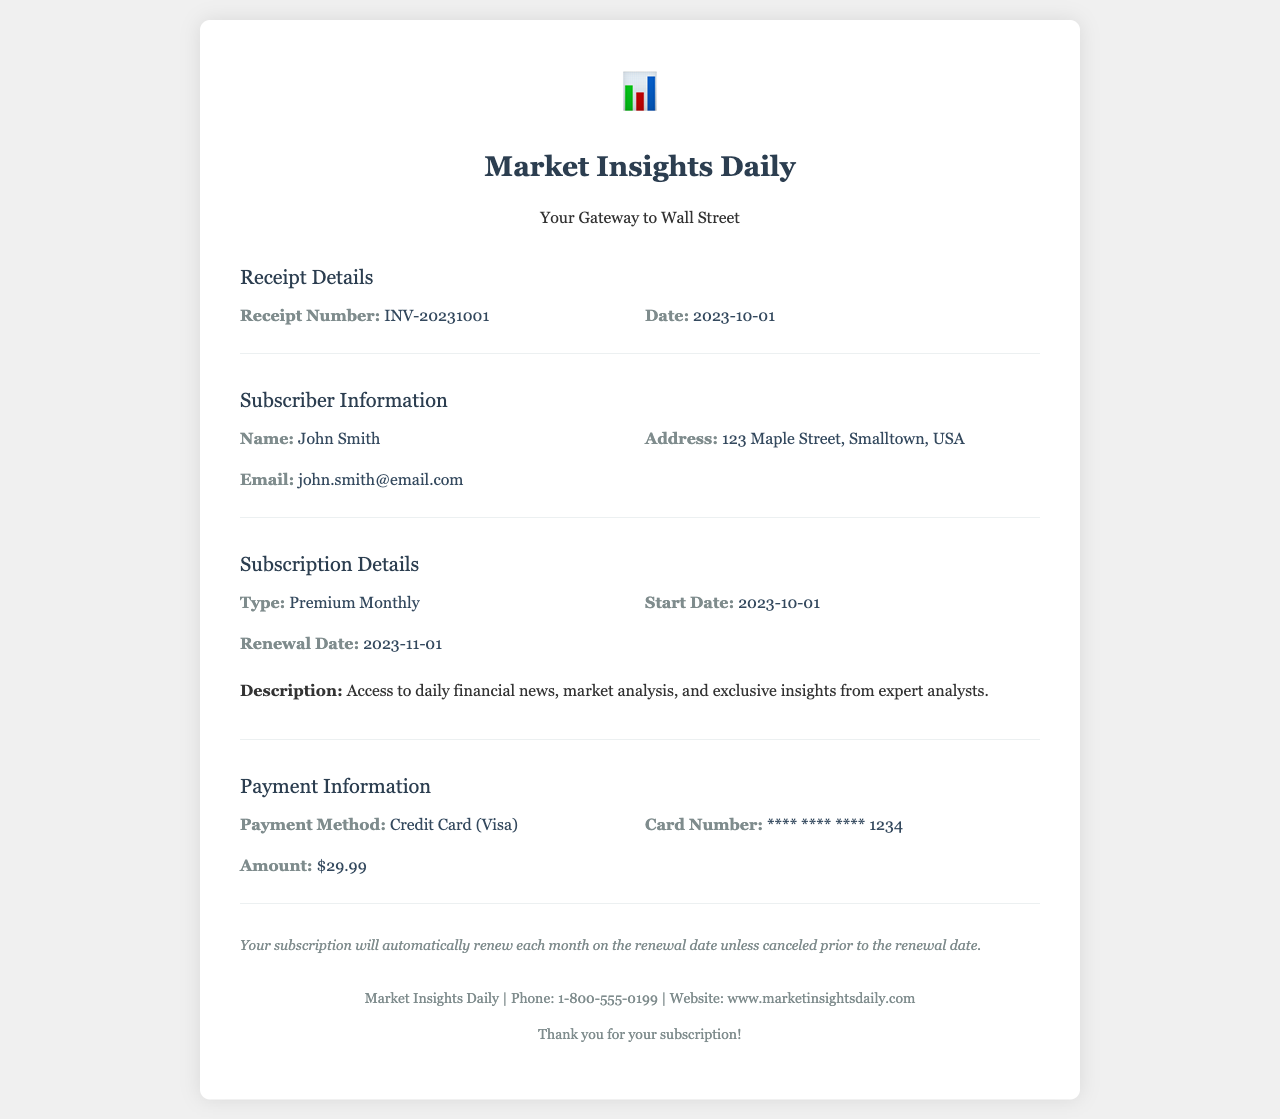what is the receipt number? The receipt number is a unique identifier for this transaction, which is listed in the document.
Answer: INV-20231001 what is the renewal date? The renewal date indicates when the subscription will renew automatically unless canceled, found in the Subscription Details section.
Answer: 2023-11-01 who is the subscriber? The subscriber's name is provided under Subscriber Information in the document.
Answer: John Smith what is the payment method? The payment method specifies how the payment was made, as detailed in the Payment Information section.
Answer: Credit Card (Visa) what amount was charged? The amount charged is listed in the Payment Information section of the receipt.
Answer: $29.99 what is the start date of the subscription? The start date indicates when the subscription began, found in Subscription Details.
Answer: 2023-10-01 what description of services is provided? The description outlines what services are included in the subscription, summarized in the Subscription Details.
Answer: Access to daily financial news, market analysis, and exclusive insights from expert analysts how often does the subscription renew? This part of the document specifies the renewal frequency for the subscription.
Answer: Monthly what is the subscriber's email? The subscriber's email is included in the Subscriber Information section for contact purposes.
Answer: john.smith@email.com 